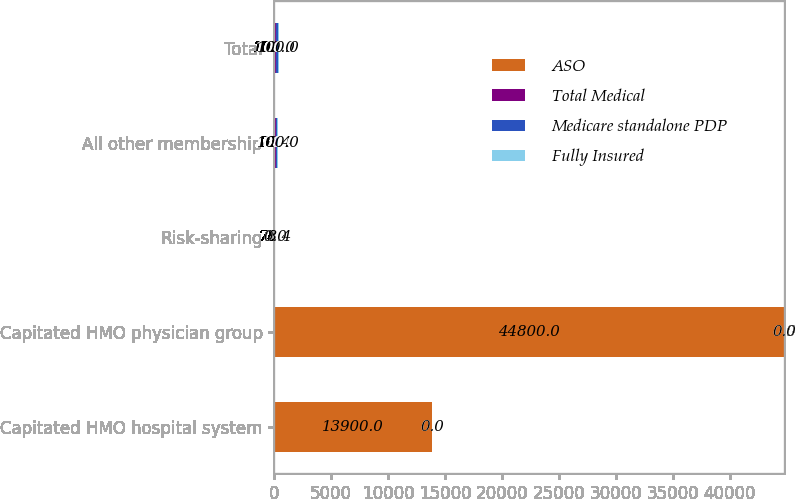Convert chart. <chart><loc_0><loc_0><loc_500><loc_500><stacked_bar_chart><ecel><fcel>Capitated HMO hospital system<fcel>Capitated HMO physician group<fcel>Risk-sharing<fcel>All other membership<fcel>Total<nl><fcel>ASO<fcel>13900<fcel>44800<fcel>78.4<fcel>78.4<fcel>100<nl><fcel>Total Medical<fcel>0<fcel>0<fcel>0<fcel>100<fcel>100<nl><fcel>Medicare standalone PDP<fcel>0<fcel>0<fcel>0<fcel>100<fcel>100<nl><fcel>Fully Insured<fcel>0<fcel>0<fcel>0<fcel>100<fcel>100<nl></chart> 